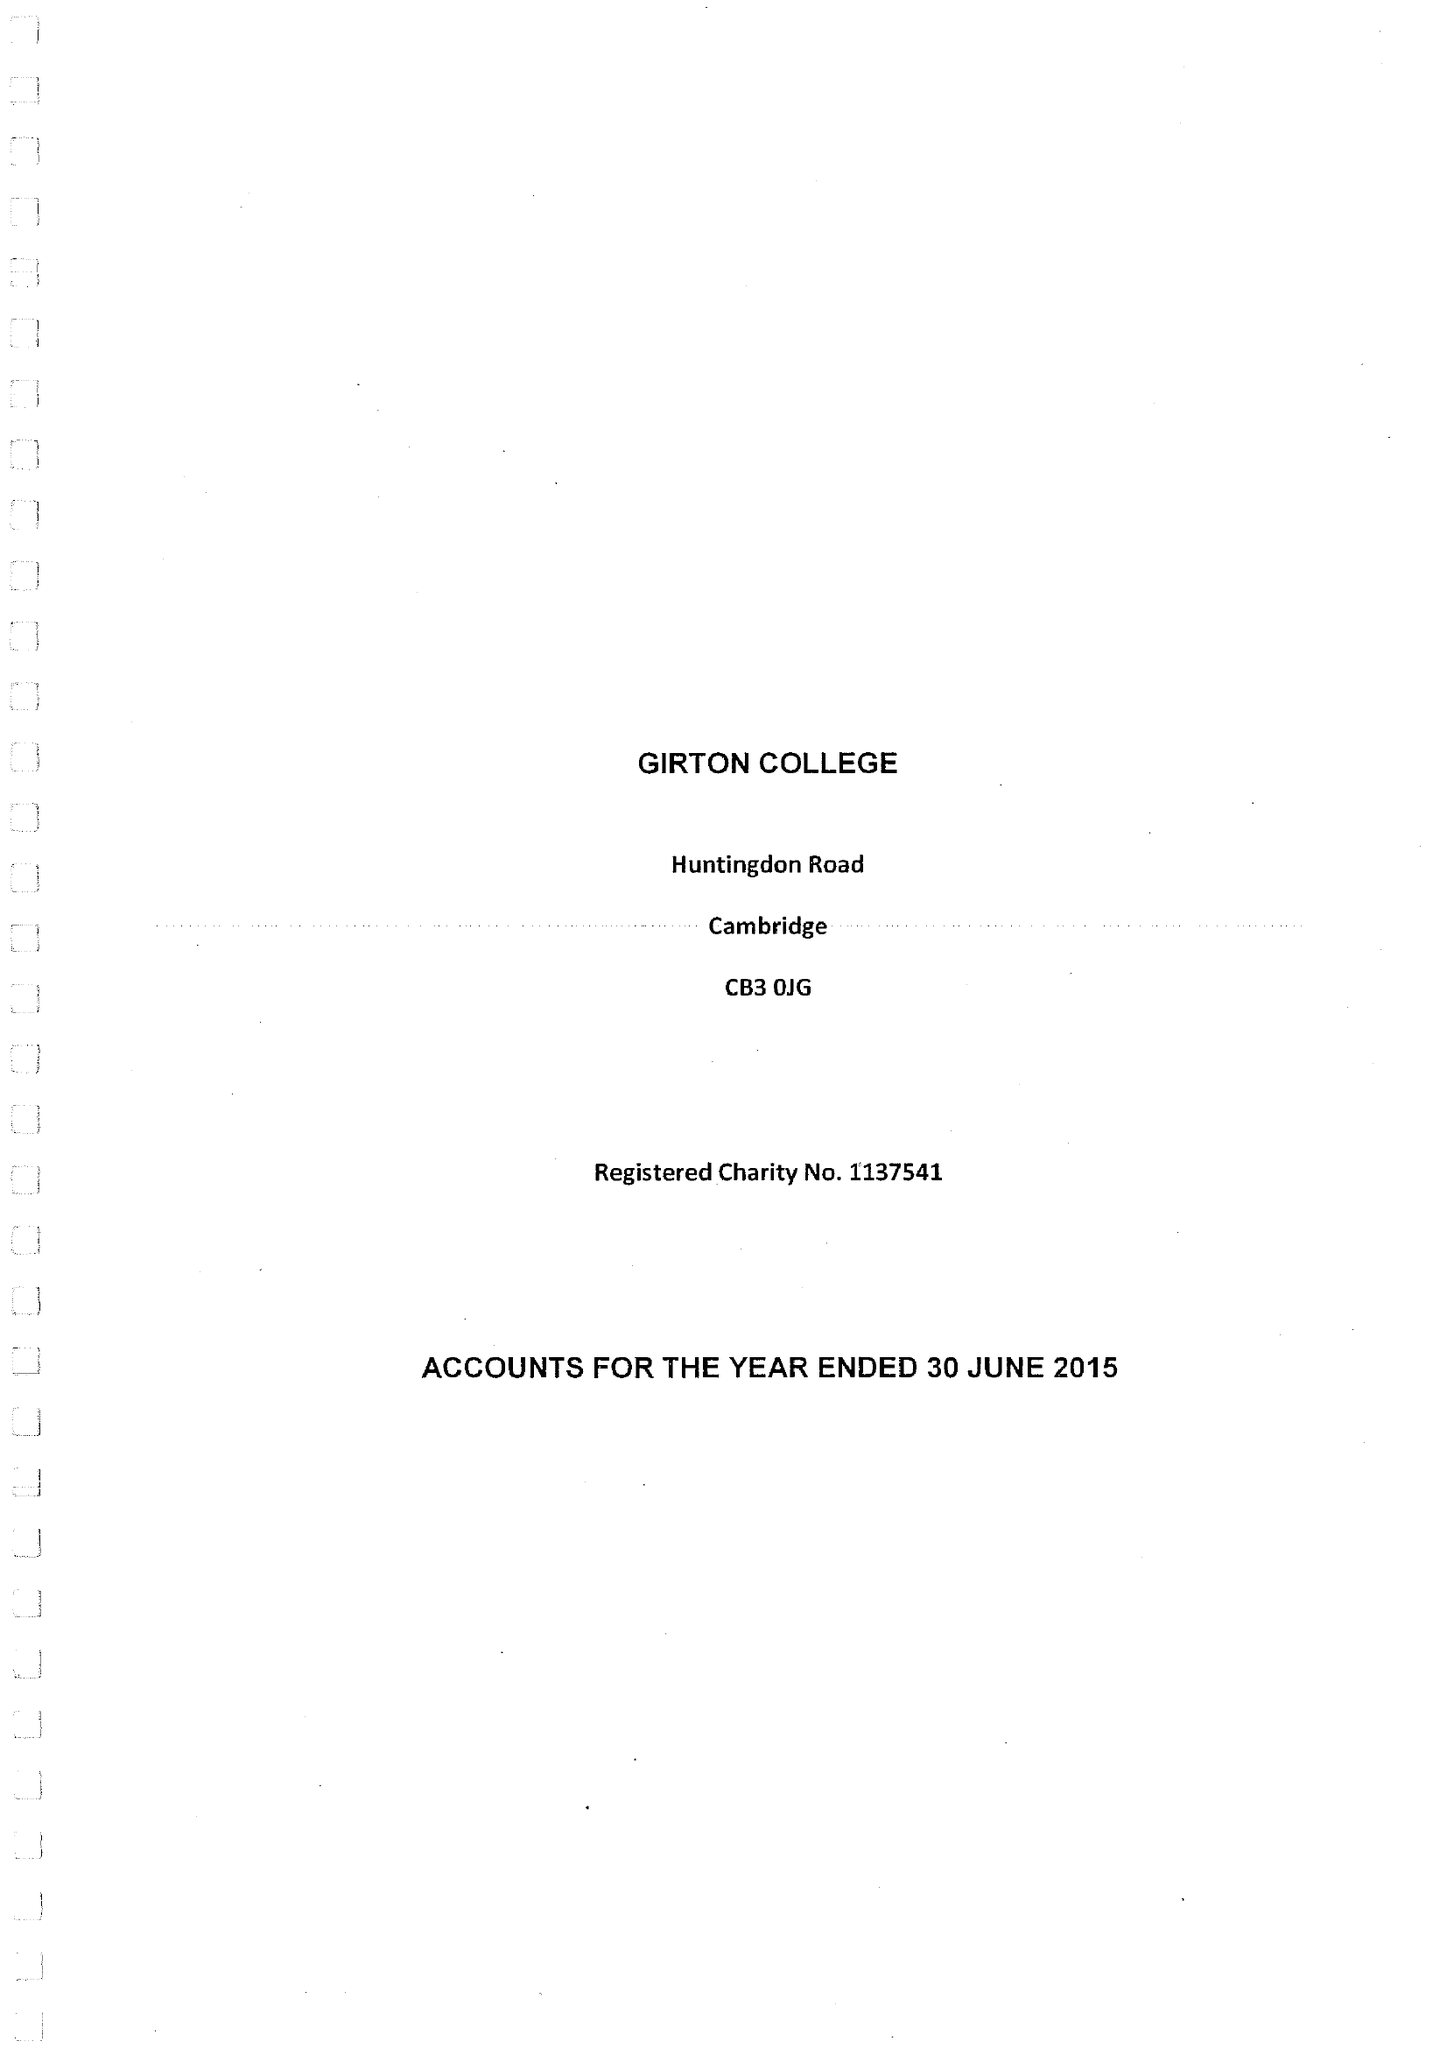What is the value for the address__postcode?
Answer the question using a single word or phrase. CB3 0JG 